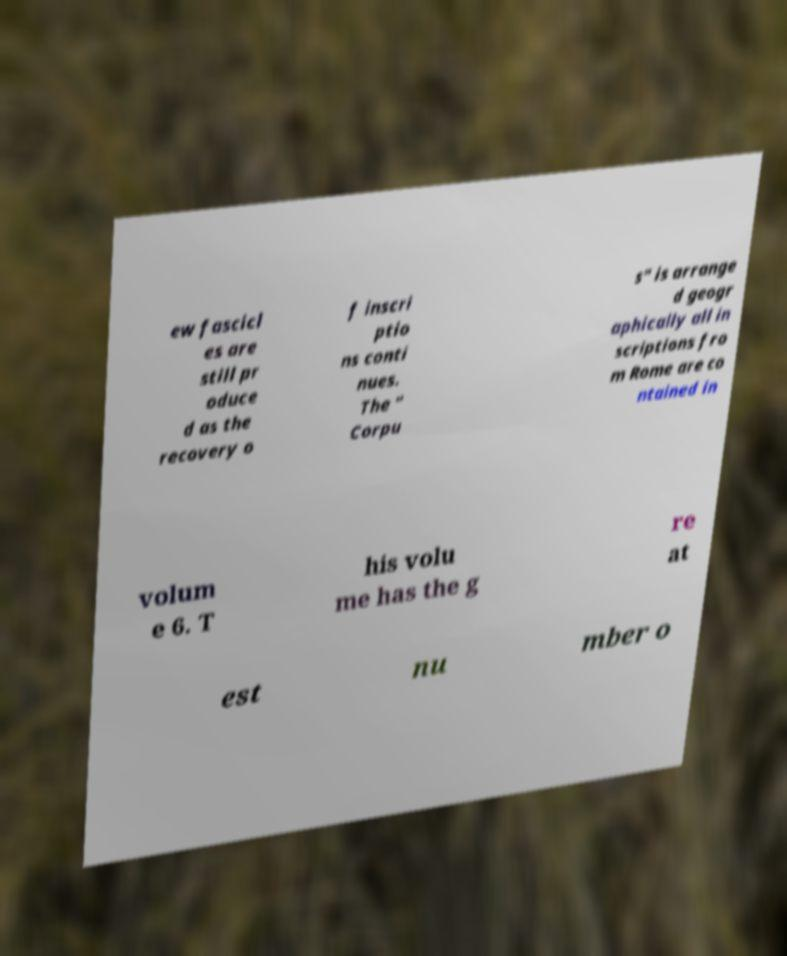Can you accurately transcribe the text from the provided image for me? ew fascicl es are still pr oduce d as the recovery o f inscri ptio ns conti nues. The " Corpu s" is arrange d geogr aphically all in scriptions fro m Rome are co ntained in volum e 6. T his volu me has the g re at est nu mber o 